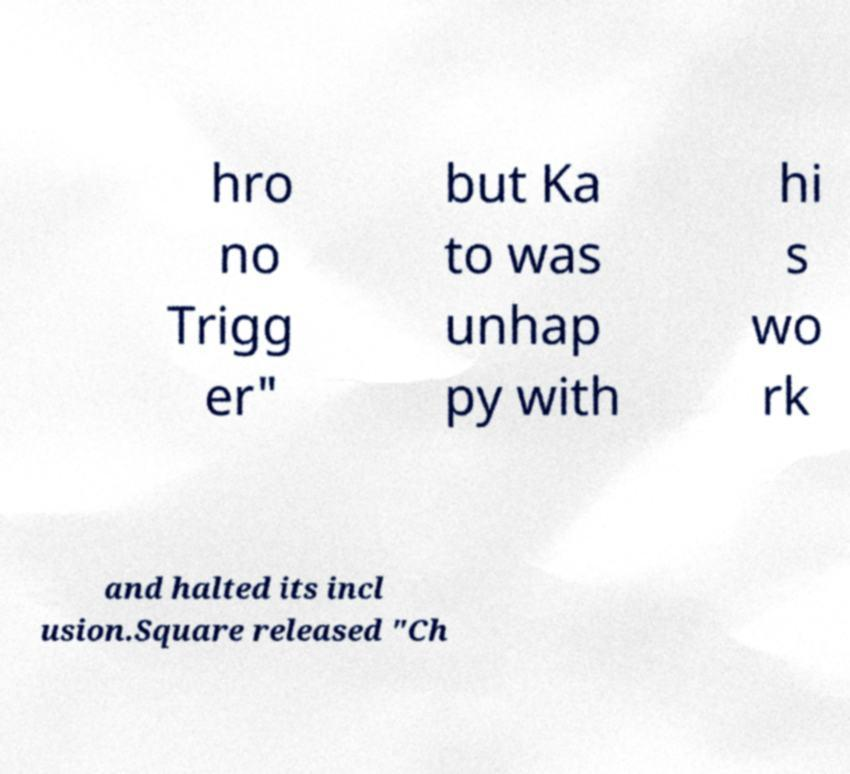Could you extract and type out the text from this image? hro no Trigg er" but Ka to was unhap py with hi s wo rk and halted its incl usion.Square released "Ch 